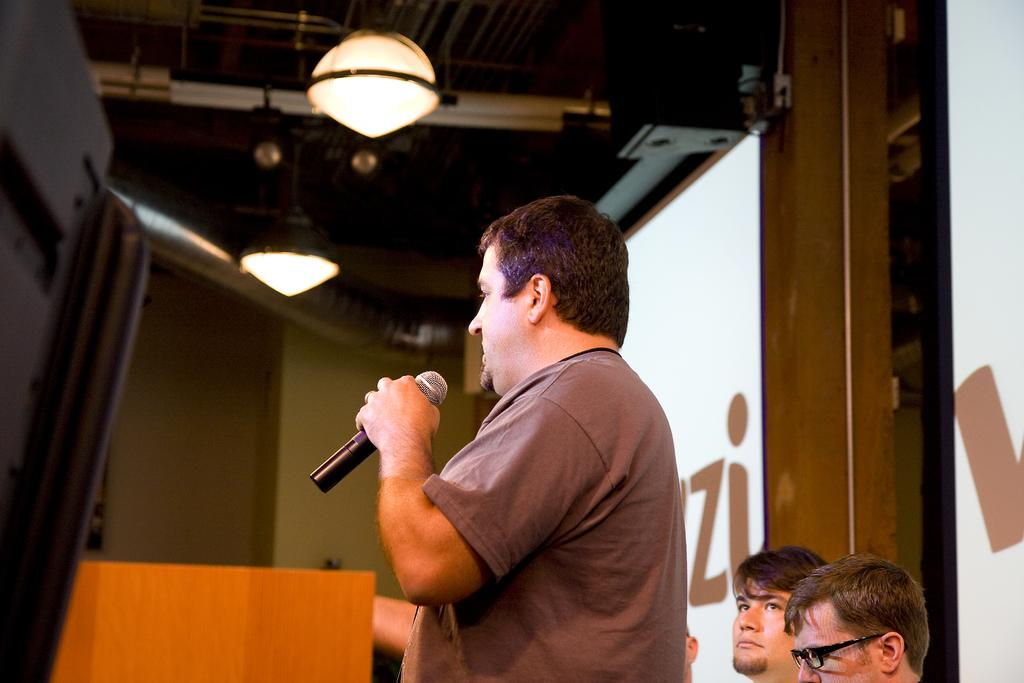What is the person in the foreground of the image doing? The person is standing and holding a mic in the image. Can you describe the background of the image? There are other persons visible in the background of the image, as well as a screen. What is the source of illumination in the image? There is a light visible at the top of the image. What type of sweater is the person wearing in the image? The person in the image is not wearing a sweater; they are holding a mic. Can you read the letter that is being displayed on the screen in the image? There is no letter visible on the screen in the image. 